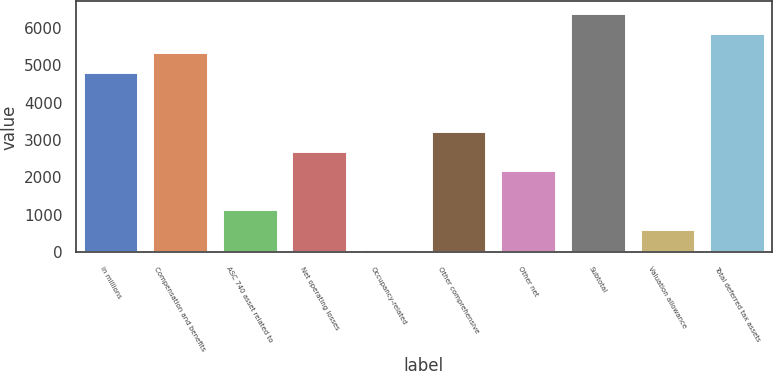Convert chart. <chart><loc_0><loc_0><loc_500><loc_500><bar_chart><fcel>in millions<fcel>Compensation and benefits<fcel>ASC 740 asset related to<fcel>Net operating losses<fcel>Occupancy-related<fcel>Other comprehensive<fcel>Other net<fcel>Subtotal<fcel>Valuation allowance<fcel>Total deferred tax assets<nl><fcel>4813.3<fcel>5337<fcel>1147.4<fcel>2718.5<fcel>100<fcel>3242.2<fcel>2194.8<fcel>6384.4<fcel>623.7<fcel>5860.7<nl></chart> 